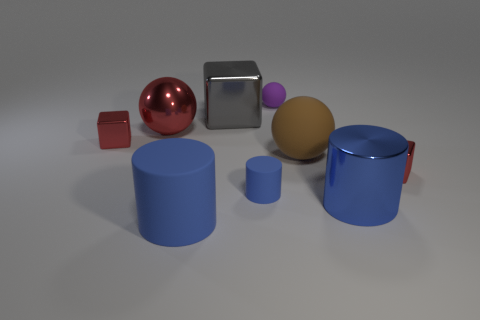What is the shape of the small object that is the same material as the tiny ball? cylinder 